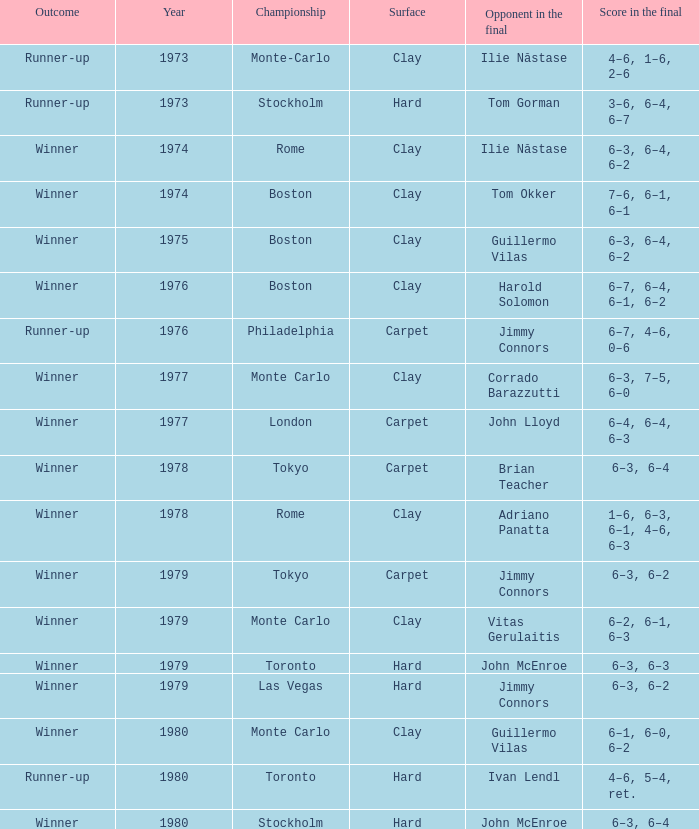Name the total number of opponent in the final for 6–2, 6–1, 6–3 1.0. 